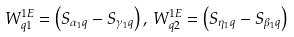Convert formula to latex. <formula><loc_0><loc_0><loc_500><loc_500>W _ { q 1 } ^ { 1 E } = \left ( S _ { \alpha _ { 1 } q } - S _ { \gamma _ { 1 } q } \right ) , \, W _ { q 2 } ^ { 1 E } = \left ( S _ { \eta _ { 1 } q } - S _ { \beta _ { 1 } q } \right )</formula> 